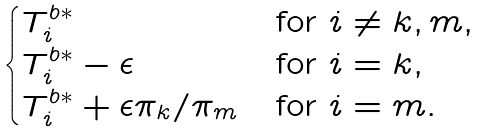<formula> <loc_0><loc_0><loc_500><loc_500>\begin{cases} { T } ^ { b * } _ { i } & \text {for } i \not = k , m , \\ { T } ^ { b * } _ { i } - \epsilon & \text {for } i = k , \\ { T } ^ { b * } _ { i } + \epsilon \pi _ { k } / \pi _ { m } & \text {for } i = m . \end{cases}</formula> 